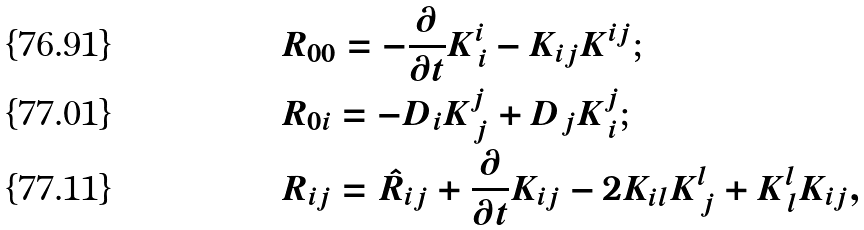Convert formula to latex. <formula><loc_0><loc_0><loc_500><loc_500>& R _ { 0 0 } = - \frac { \partial } { \partial t } K ^ { i } _ { \, i } - K _ { i j } K ^ { i j } ; \\ & R _ { 0 i } = - D _ { i } K ^ { j } _ { \, j } + D _ { j } K ^ { j } _ { \, i } ; \\ & R _ { i j } = \hat { R } _ { i j } + \frac { \partial } { \partial t } K _ { i j } - 2 K _ { i l } K ^ { l } _ { \, j } + K ^ { l } _ { \, l } K _ { i j } ,</formula> 